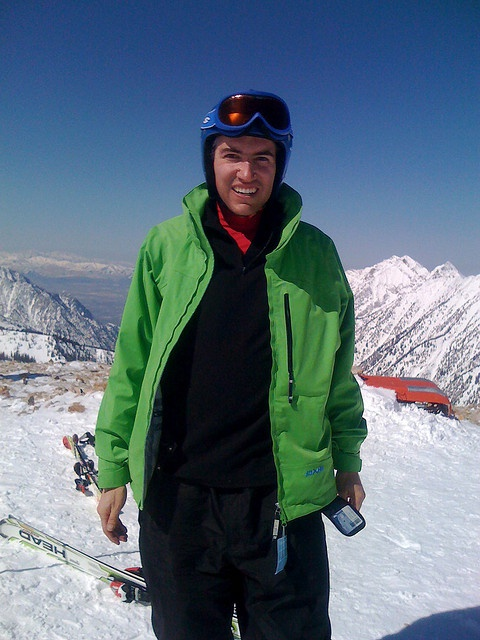Describe the objects in this image and their specific colors. I can see people in darkblue, black, green, darkgreen, and maroon tones, skis in darkblue, lightgray, darkgray, black, and gray tones, car in darkblue, brown, gray, and darkgray tones, skis in darkblue, lightgray, gray, darkgray, and black tones, and cell phone in darkblue, black, navy, darkgray, and gray tones in this image. 